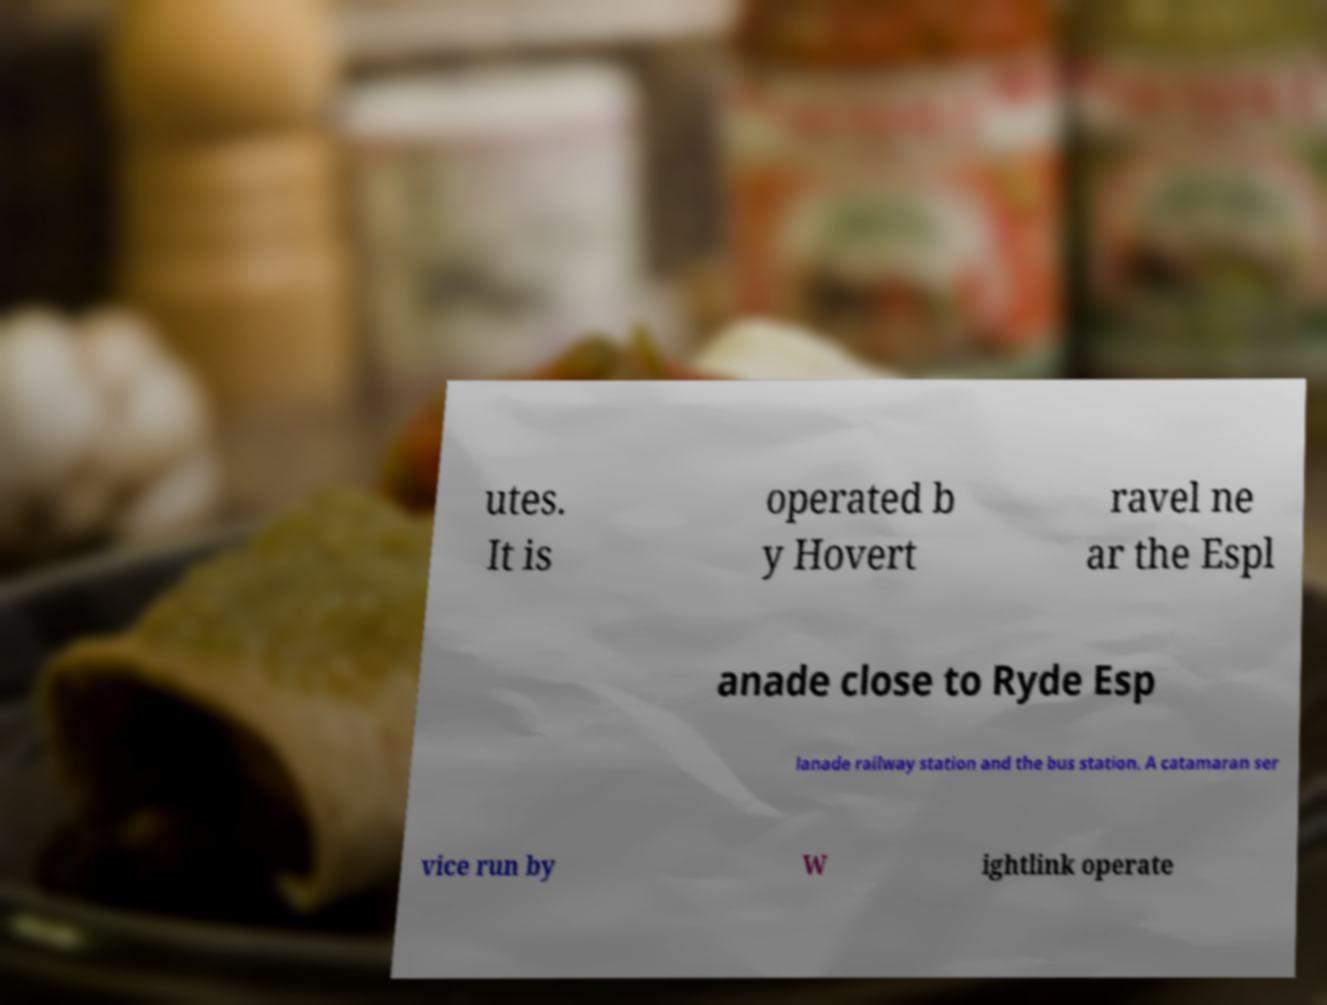What messages or text are displayed in this image? I need them in a readable, typed format. utes. It is operated b y Hovert ravel ne ar the Espl anade close to Ryde Esp lanade railway station and the bus station. A catamaran ser vice run by W ightlink operate 